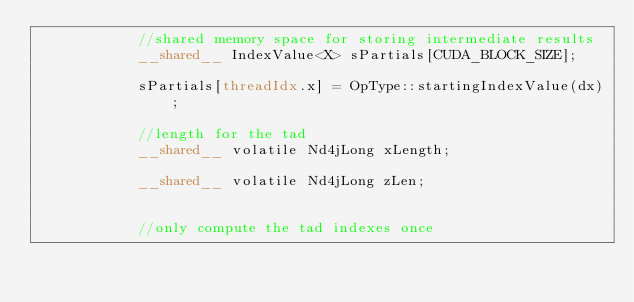Convert code to text. <code><loc_0><loc_0><loc_500><loc_500><_Cuda_>            //shared memory space for storing intermediate results
            __shared__ IndexValue<X> sPartials[CUDA_BLOCK_SIZE];

            sPartials[threadIdx.x] = OpType::startingIndexValue(dx);

            //length for the tad
            __shared__ volatile Nd4jLong xLength;

            __shared__ volatile Nd4jLong zLen;


            //only compute the tad indexes once</code> 